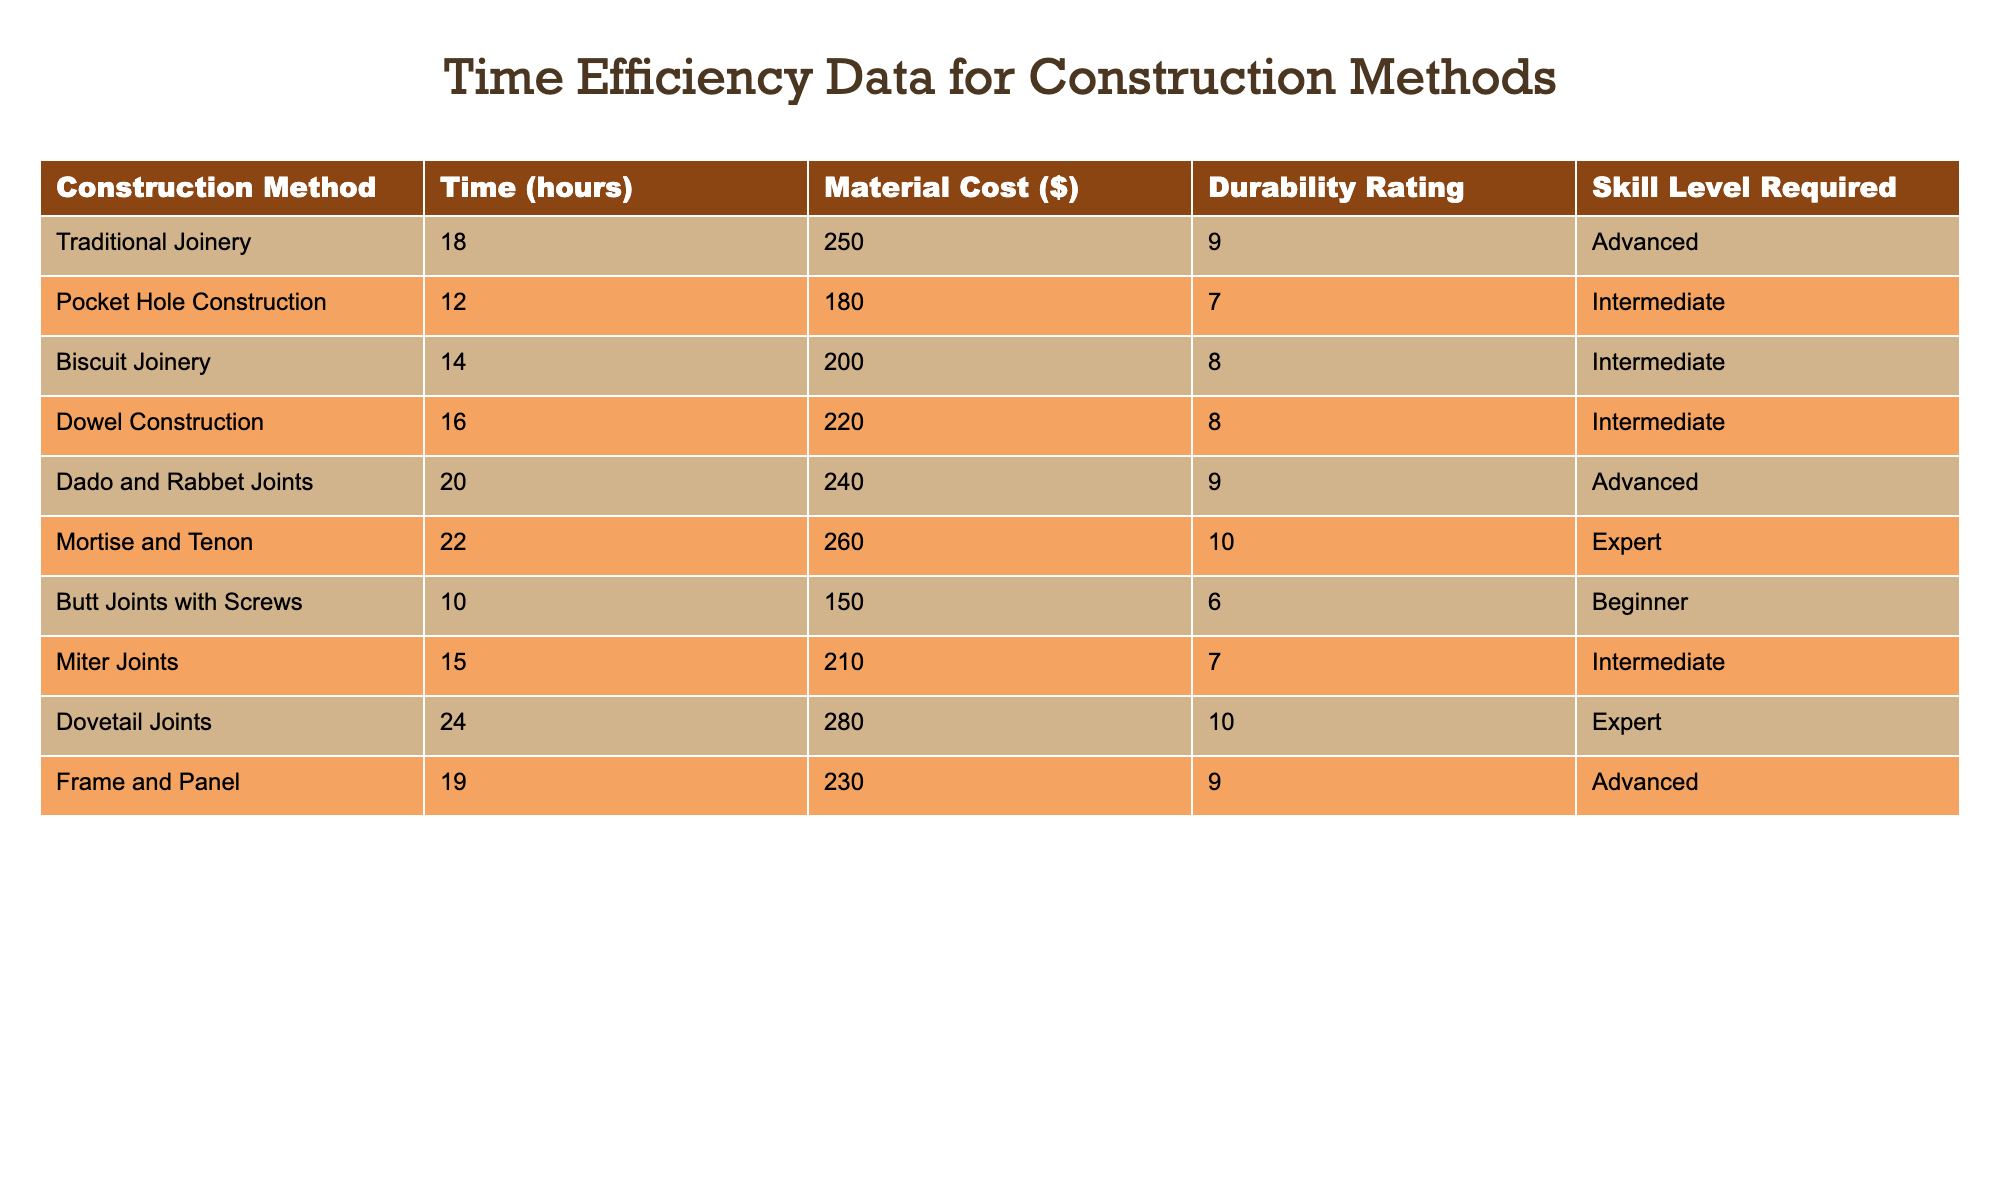What construction method takes the least time? The table shows that Butt Joints with Screws take the least time at 10 hours.
Answer: Butt Joints with Screws How many hours does Traditional Joinery take? The table lists Traditional Joinery as taking 18 hours.
Answer: 18 hours What is the material cost of Dovetail Joints? The table indicates that Dovetail Joints have a material cost of $280.
Answer: $280 Which construction methods require intermediate skill level? The table mentions three methods requiring intermediate skill level: Pocket Hole Construction, Biscuit Joinery, and Dowel Construction.
Answer: Pocket Hole Construction, Biscuit Joinery, Dowel Construction What is the difference in time between Dado and Rabbet Joints and Mortise and Tenon methods? Dado and Rabbet Joints take 20 hours while Mortise and Tenon take 22 hours. Therefore, the difference is 22 - 20 = 2 hours.
Answer: 2 hours Is the durability rating for Butt Joints with Screws greater than 5? The table shows that Butt Joints with Screws have a durability rating of 6, which is greater than 5.
Answer: Yes What is the average time taken for all methods listed? The sum of all times (18 + 12 + 14 + 16 + 20 + 22 + 10 + 15 + 24 + 19) equals 180 hours, and there are 10 methods, thus the average is 180/10 = 18 hours.
Answer: 18 hours Which construction method has the highest durability rating? The table shows that Mortise and Tenon and Dovetail Joints both have the highest durability rating of 10.
Answer: Mortise and Tenon, Dovetail Joints What is the total material cost of the methods that require an advanced skill level? The advanced methods are Traditional Joinery, Dado and Rabbet Joints, and Frame and Panel. Their costs are $250, $240, and $230 respectively. The total is 250 + 240 + 230 = $720.
Answer: $720 Is there any construction method that requires a beginner skill level? The table demonstrates that Butt Joints with Screws is the only method that requires a beginner skill level.
Answer: Yes 